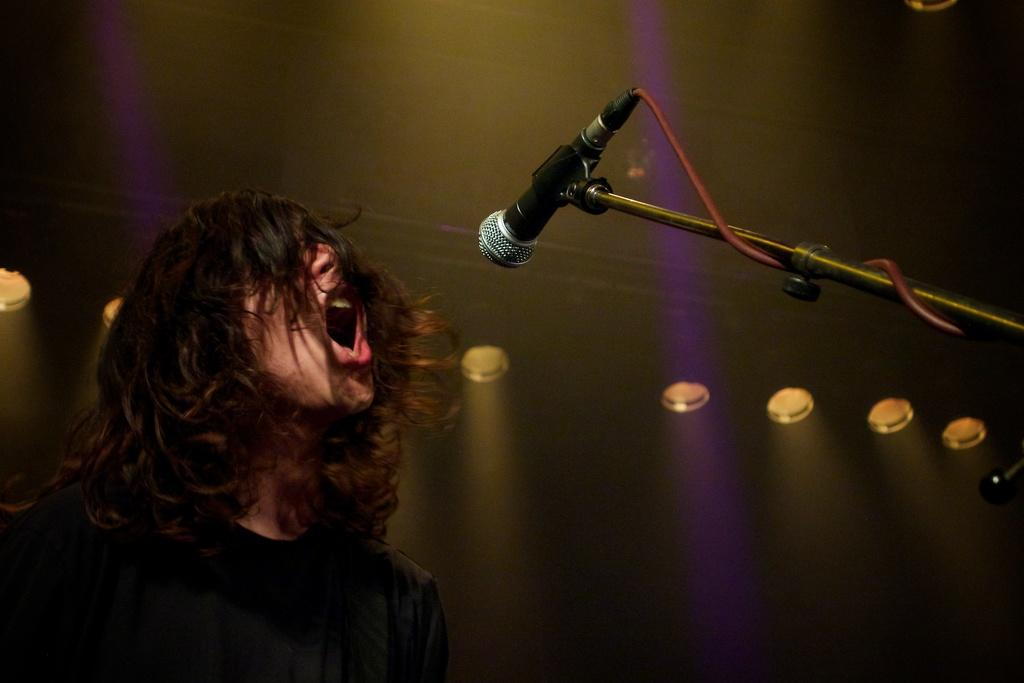Who is the main subject in the image? There is a boy in the image. Where is the boy positioned in the image? The boy is on the left side of the image. What object is in front of the boy? There is a mic in front of the boy. What can be seen in the background of the image? There are spotlights in the background of the image. What color is the boy's tongue in the image? There is no information about the boy's tongue in the image, so we cannot determine its color. 